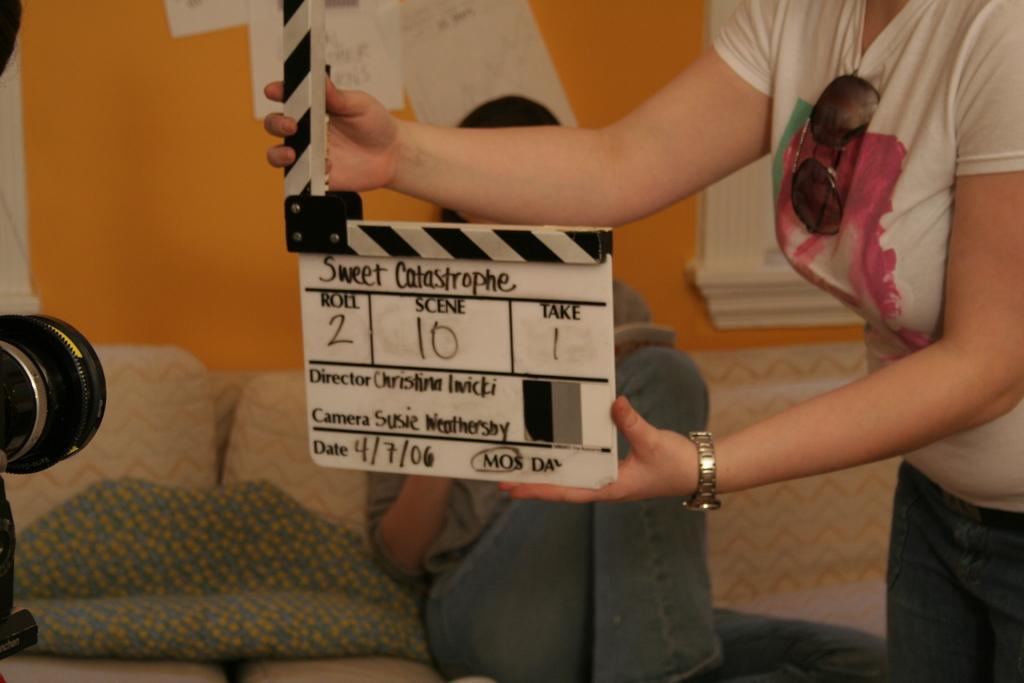How would you summarize this image in a sentence or two? This image is taken indoors. On the right side of the image a woman is standing on the floor and she is holding a board with a text on it. On the left side of the image there is a camera. In the middle of the image a man is sitting on the couch. In the background there is a wall. 